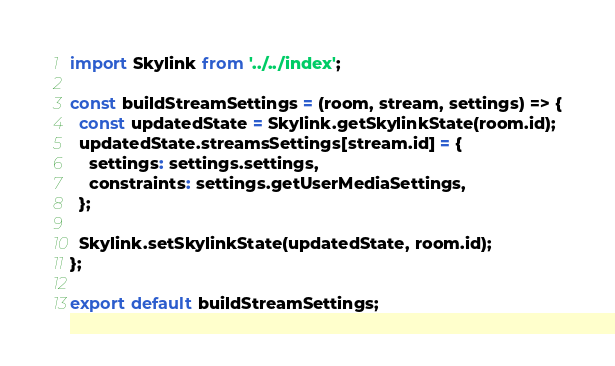Convert code to text. <code><loc_0><loc_0><loc_500><loc_500><_JavaScript_>import Skylink from '../../index';

const buildStreamSettings = (room, stream, settings) => {
  const updatedState = Skylink.getSkylinkState(room.id);
  updatedState.streamsSettings[stream.id] = {
    settings: settings.settings,
    constraints: settings.getUserMediaSettings,
  };

  Skylink.setSkylinkState(updatedState, room.id);
};

export default buildStreamSettings;
</code> 